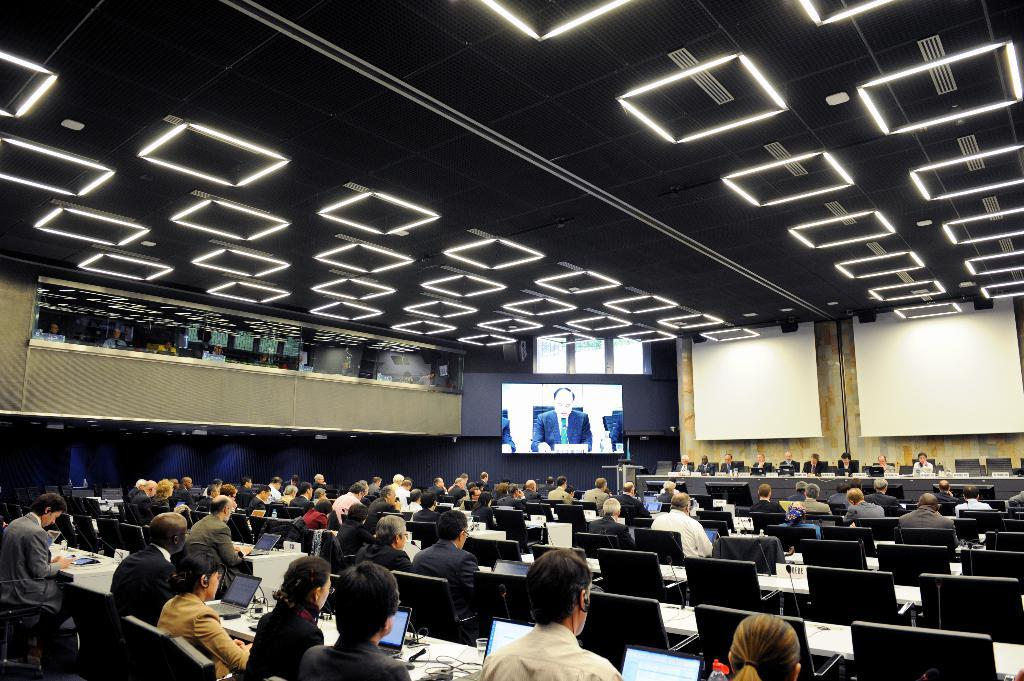What is above the people in the image? There is a ceiling in the image. What can be seen on the wall in the image? There is a screen in the image. What are the people sitting on in the image? People are sitting on chairs in the image. What is on the tables in the image? Laptops are present on the tables. How many tables are visible in the image? There are tables in the image, but the exact number is not specified. Can you tell me what time it is on the clock in the image? There is no clock present in the image. Is there a lake visible in the image? There is no lake present in the image. 